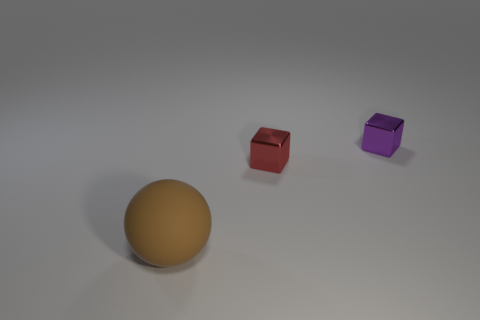Does the shiny object in front of the purple shiny cube have the same size as the rubber sphere?
Offer a very short reply. No. How many other objects are there of the same material as the small purple object?
Provide a succinct answer. 1. Are there more cylinders than brown rubber spheres?
Ensure brevity in your answer.  No. What is the material of the cube that is left of the small object that is to the right of the small cube in front of the small purple block?
Offer a very short reply. Metal. Is there a thing that has the same color as the large ball?
Your response must be concise. No. What is the shape of the red shiny object that is the same size as the purple shiny object?
Provide a succinct answer. Cube. Are there fewer purple blocks than big green metal balls?
Keep it short and to the point. No. How many other objects have the same size as the purple metallic thing?
Provide a short and direct response. 1. What material is the small purple object?
Your answer should be very brief. Metal. What is the size of the thing on the left side of the small red object?
Your answer should be very brief. Large. 